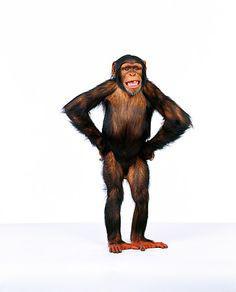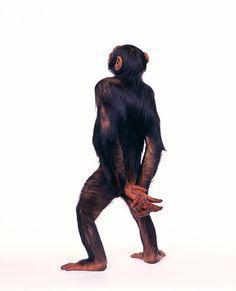The first image is the image on the left, the second image is the image on the right. For the images shown, is this caption "In one of the images a monkey is on all four legs." true? Answer yes or no. No. The first image is the image on the left, the second image is the image on the right. Examine the images to the left and right. Is the description "One chimp is standing on four feet." accurate? Answer yes or no. No. 